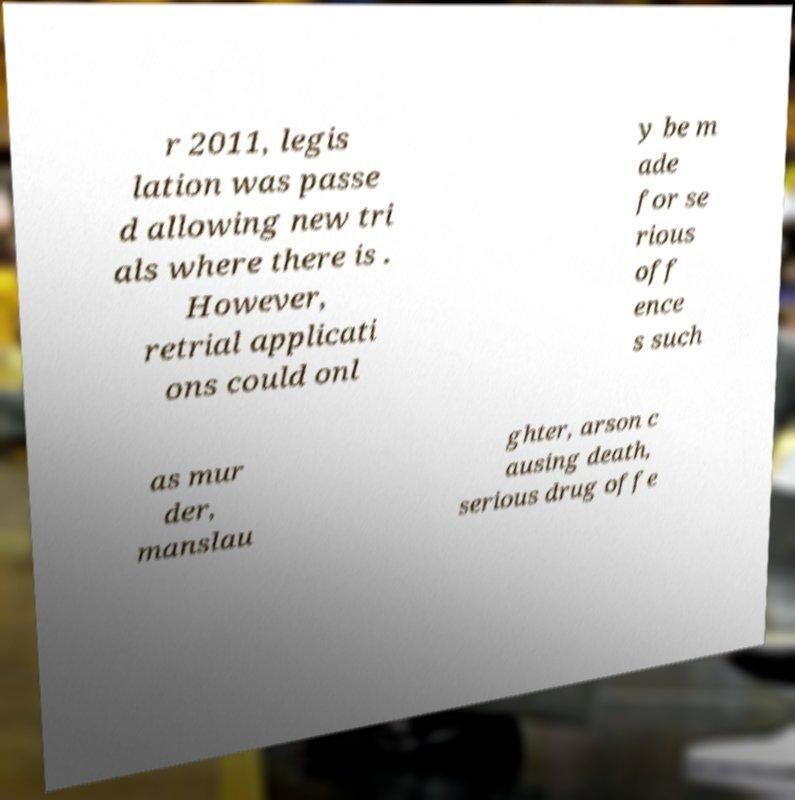There's text embedded in this image that I need extracted. Can you transcribe it verbatim? r 2011, legis lation was passe d allowing new tri als where there is . However, retrial applicati ons could onl y be m ade for se rious off ence s such as mur der, manslau ghter, arson c ausing death, serious drug offe 